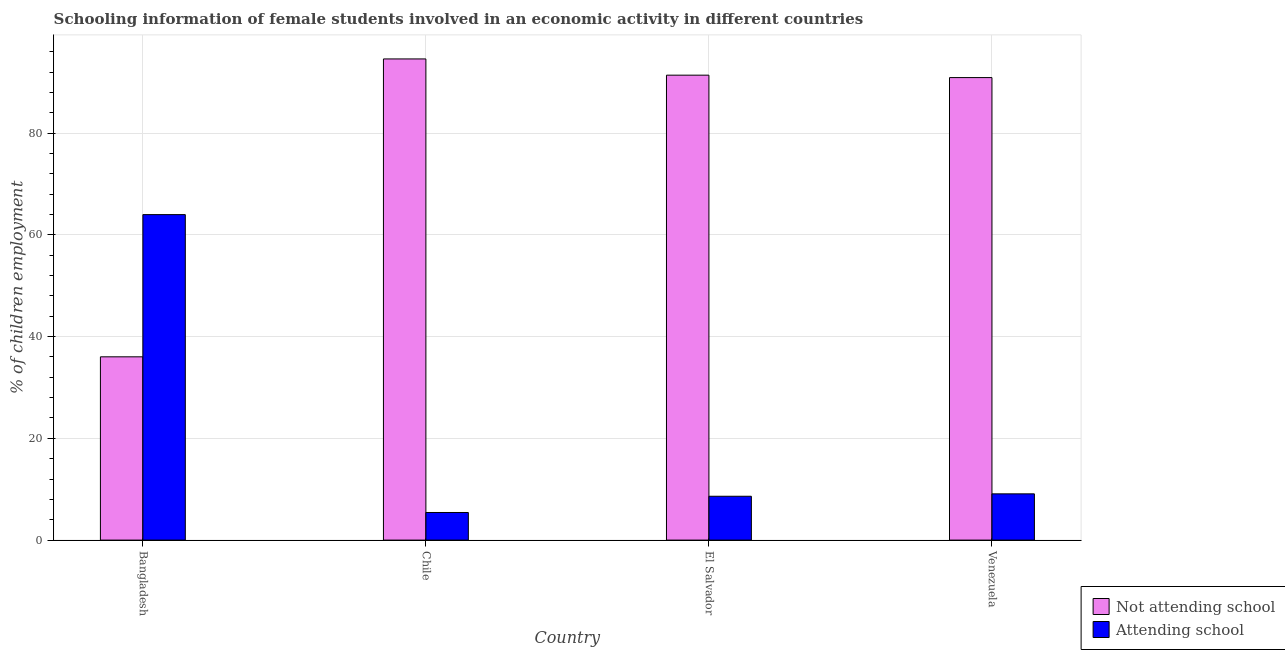How many different coloured bars are there?
Keep it short and to the point. 2. Are the number of bars per tick equal to the number of legend labels?
Give a very brief answer. Yes. How many bars are there on the 4th tick from the left?
Make the answer very short. 2. What is the label of the 3rd group of bars from the left?
Offer a very short reply. El Salvador. In how many cases, is the number of bars for a given country not equal to the number of legend labels?
Your answer should be very brief. 0. What is the percentage of employed females who are not attending school in Bangladesh?
Ensure brevity in your answer.  36.02. Across all countries, what is the maximum percentage of employed females who are not attending school?
Provide a short and direct response. 94.57. Across all countries, what is the minimum percentage of employed females who are attending school?
Ensure brevity in your answer.  5.43. In which country was the percentage of employed females who are not attending school maximum?
Your answer should be very brief. Chile. In which country was the percentage of employed females who are attending school minimum?
Ensure brevity in your answer.  Chile. What is the total percentage of employed females who are not attending school in the graph?
Provide a short and direct response. 312.89. What is the difference between the percentage of employed females who are not attending school in Chile and that in Venezuela?
Provide a succinct answer. 3.67. What is the difference between the percentage of employed females who are not attending school in Venezuela and the percentage of employed females who are attending school in El Salvador?
Offer a very short reply. 82.29. What is the average percentage of employed females who are not attending school per country?
Offer a very short reply. 78.22. What is the difference between the percentage of employed females who are not attending school and percentage of employed females who are attending school in Chile?
Your answer should be compact. 89.15. What is the ratio of the percentage of employed females who are attending school in Chile to that in Venezuela?
Provide a short and direct response. 0.6. What is the difference between the highest and the second highest percentage of employed females who are not attending school?
Provide a short and direct response. 3.19. What is the difference between the highest and the lowest percentage of employed females who are attending school?
Your response must be concise. 58.55. Is the sum of the percentage of employed females who are not attending school in Bangladesh and El Salvador greater than the maximum percentage of employed females who are attending school across all countries?
Provide a short and direct response. Yes. What does the 1st bar from the left in El Salvador represents?
Your answer should be very brief. Not attending school. What does the 1st bar from the right in Bangladesh represents?
Provide a short and direct response. Attending school. Are all the bars in the graph horizontal?
Make the answer very short. No. How many countries are there in the graph?
Offer a terse response. 4. What is the difference between two consecutive major ticks on the Y-axis?
Your answer should be compact. 20. Are the values on the major ticks of Y-axis written in scientific E-notation?
Offer a very short reply. No. Does the graph contain any zero values?
Offer a very short reply. No. Where does the legend appear in the graph?
Ensure brevity in your answer.  Bottom right. What is the title of the graph?
Provide a short and direct response. Schooling information of female students involved in an economic activity in different countries. Does "External balance on goods" appear as one of the legend labels in the graph?
Provide a succinct answer. No. What is the label or title of the Y-axis?
Provide a succinct answer. % of children employment. What is the % of children employment of Not attending school in Bangladesh?
Provide a short and direct response. 36.02. What is the % of children employment in Attending school in Bangladesh?
Keep it short and to the point. 63.98. What is the % of children employment of Not attending school in Chile?
Your answer should be compact. 94.57. What is the % of children employment in Attending school in Chile?
Your answer should be very brief. 5.43. What is the % of children employment in Not attending school in El Salvador?
Provide a succinct answer. 91.38. What is the % of children employment in Attending school in El Salvador?
Your response must be concise. 8.62. What is the % of children employment in Not attending school in Venezuela?
Give a very brief answer. 90.91. What is the % of children employment of Attending school in Venezuela?
Make the answer very short. 9.09. Across all countries, what is the maximum % of children employment in Not attending school?
Give a very brief answer. 94.57. Across all countries, what is the maximum % of children employment in Attending school?
Your response must be concise. 63.98. Across all countries, what is the minimum % of children employment of Not attending school?
Your answer should be very brief. 36.02. Across all countries, what is the minimum % of children employment in Attending school?
Your answer should be very brief. 5.43. What is the total % of children employment in Not attending school in the graph?
Provide a succinct answer. 312.89. What is the total % of children employment of Attending school in the graph?
Your answer should be very brief. 87.11. What is the difference between the % of children employment in Not attending school in Bangladesh and that in Chile?
Your answer should be very brief. -58.55. What is the difference between the % of children employment of Attending school in Bangladesh and that in Chile?
Make the answer very short. 58.55. What is the difference between the % of children employment of Not attending school in Bangladesh and that in El Salvador?
Your answer should be very brief. -55.36. What is the difference between the % of children employment of Attending school in Bangladesh and that in El Salvador?
Give a very brief answer. 55.36. What is the difference between the % of children employment in Not attending school in Bangladesh and that in Venezuela?
Give a very brief answer. -54.88. What is the difference between the % of children employment in Attending school in Bangladesh and that in Venezuela?
Your response must be concise. 54.88. What is the difference between the % of children employment of Not attending school in Chile and that in El Salvador?
Keep it short and to the point. 3.19. What is the difference between the % of children employment of Attending school in Chile and that in El Salvador?
Offer a terse response. -3.19. What is the difference between the % of children employment of Not attending school in Chile and that in Venezuela?
Give a very brief answer. 3.67. What is the difference between the % of children employment of Attending school in Chile and that in Venezuela?
Your answer should be compact. -3.67. What is the difference between the % of children employment of Not attending school in El Salvador and that in Venezuela?
Offer a very short reply. 0.47. What is the difference between the % of children employment in Attending school in El Salvador and that in Venezuela?
Ensure brevity in your answer.  -0.47. What is the difference between the % of children employment in Not attending school in Bangladesh and the % of children employment in Attending school in Chile?
Your answer should be compact. 30.6. What is the difference between the % of children employment of Not attending school in Bangladesh and the % of children employment of Attending school in El Salvador?
Your answer should be compact. 27.41. What is the difference between the % of children employment in Not attending school in Bangladesh and the % of children employment in Attending school in Venezuela?
Ensure brevity in your answer.  26.93. What is the difference between the % of children employment of Not attending school in Chile and the % of children employment of Attending school in El Salvador?
Provide a succinct answer. 85.96. What is the difference between the % of children employment in Not attending school in Chile and the % of children employment in Attending school in Venezuela?
Ensure brevity in your answer.  85.48. What is the difference between the % of children employment of Not attending school in El Salvador and the % of children employment of Attending school in Venezuela?
Keep it short and to the point. 82.29. What is the average % of children employment in Not attending school per country?
Give a very brief answer. 78.22. What is the average % of children employment of Attending school per country?
Your answer should be very brief. 21.78. What is the difference between the % of children employment in Not attending school and % of children employment in Attending school in Bangladesh?
Make the answer very short. -27.95. What is the difference between the % of children employment in Not attending school and % of children employment in Attending school in Chile?
Make the answer very short. 89.15. What is the difference between the % of children employment in Not attending school and % of children employment in Attending school in El Salvador?
Offer a very short reply. 82.77. What is the difference between the % of children employment of Not attending school and % of children employment of Attending school in Venezuela?
Ensure brevity in your answer.  81.82. What is the ratio of the % of children employment of Not attending school in Bangladesh to that in Chile?
Offer a terse response. 0.38. What is the ratio of the % of children employment of Attending school in Bangladesh to that in Chile?
Your response must be concise. 11.79. What is the ratio of the % of children employment of Not attending school in Bangladesh to that in El Salvador?
Offer a very short reply. 0.39. What is the ratio of the % of children employment in Attending school in Bangladesh to that in El Salvador?
Keep it short and to the point. 7.42. What is the ratio of the % of children employment in Not attending school in Bangladesh to that in Venezuela?
Make the answer very short. 0.4. What is the ratio of the % of children employment in Attending school in Bangladesh to that in Venezuela?
Ensure brevity in your answer.  7.04. What is the ratio of the % of children employment in Not attending school in Chile to that in El Salvador?
Your answer should be compact. 1.03. What is the ratio of the % of children employment in Attending school in Chile to that in El Salvador?
Your response must be concise. 0.63. What is the ratio of the % of children employment of Not attending school in Chile to that in Venezuela?
Give a very brief answer. 1.04. What is the ratio of the % of children employment of Attending school in Chile to that in Venezuela?
Provide a succinct answer. 0.6. What is the ratio of the % of children employment of Attending school in El Salvador to that in Venezuela?
Your response must be concise. 0.95. What is the difference between the highest and the second highest % of children employment in Not attending school?
Provide a short and direct response. 3.19. What is the difference between the highest and the second highest % of children employment of Attending school?
Provide a short and direct response. 54.88. What is the difference between the highest and the lowest % of children employment in Not attending school?
Ensure brevity in your answer.  58.55. What is the difference between the highest and the lowest % of children employment in Attending school?
Offer a very short reply. 58.55. 